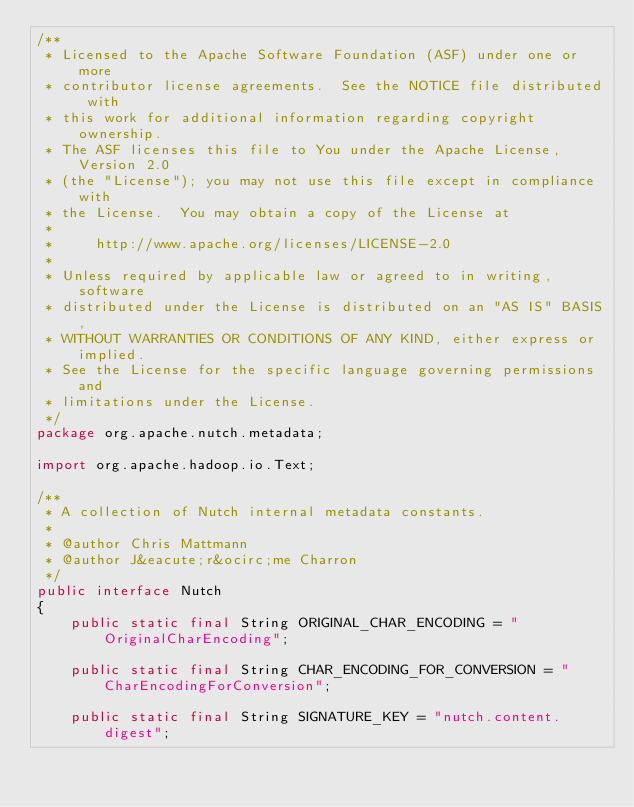Convert code to text. <code><loc_0><loc_0><loc_500><loc_500><_Java_>/**
 * Licensed to the Apache Software Foundation (ASF) under one or more
 * contributor license agreements.  See the NOTICE file distributed with
 * this work for additional information regarding copyright ownership.
 * The ASF licenses this file to You under the Apache License, Version 2.0
 * (the "License"); you may not use this file except in compliance with
 * the License.  You may obtain a copy of the License at
 *
 *     http://www.apache.org/licenses/LICENSE-2.0
 *
 * Unless required by applicable law or agreed to in writing, software
 * distributed under the License is distributed on an "AS IS" BASIS,
 * WITHOUT WARRANTIES OR CONDITIONS OF ANY KIND, either express or implied.
 * See the License for the specific language governing permissions and
 * limitations under the License.
 */
package org.apache.nutch.metadata;

import org.apache.hadoop.io.Text;

/**
 * A collection of Nutch internal metadata constants.
 *
 * @author Chris Mattmann
 * @author J&eacute;r&ocirc;me Charron
 */
public interface Nutch 
{  
	public static final String ORIGINAL_CHAR_ENCODING = "OriginalCharEncoding";
  
	public static final String CHAR_ENCODING_FOR_CONVERSION = "CharEncodingForConversion";

	public static final String SIGNATURE_KEY = "nutch.content.digest";
</code> 